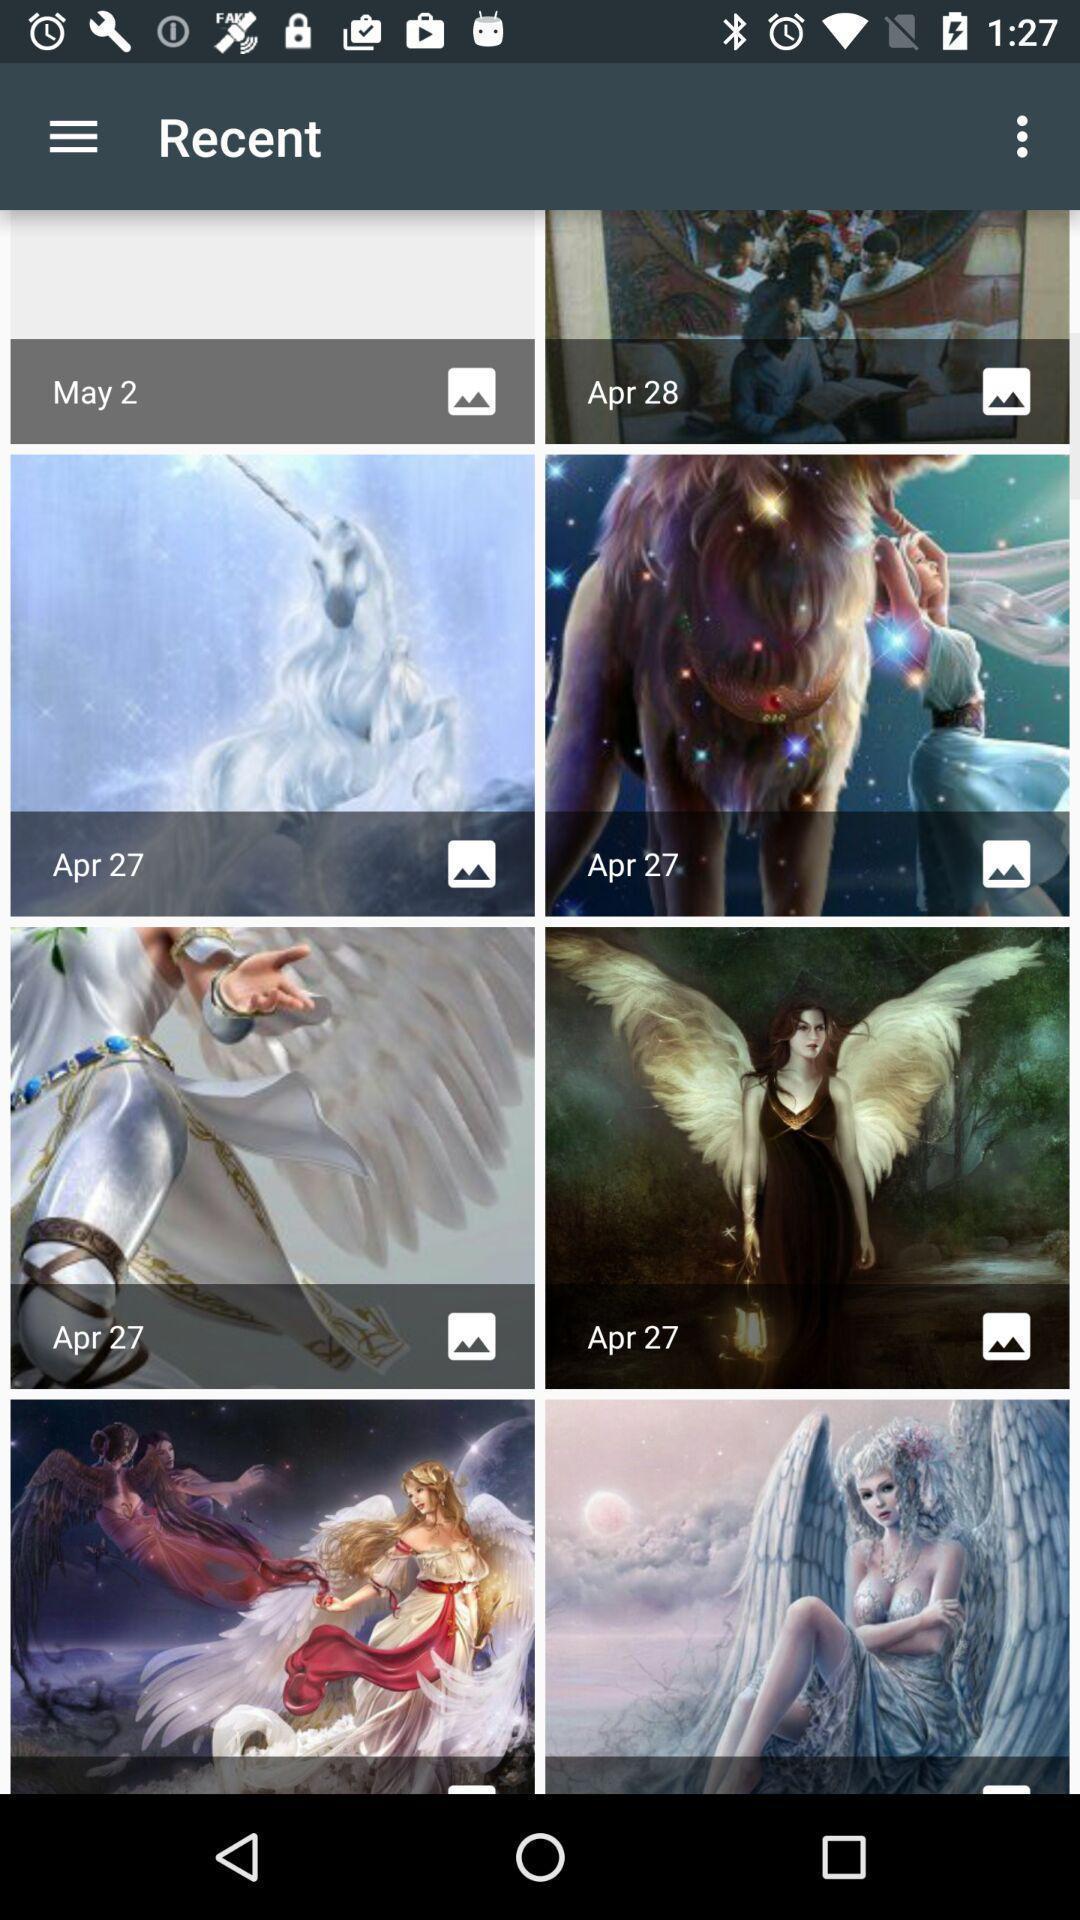Describe this image in words. Page showing different recent images on an app. 